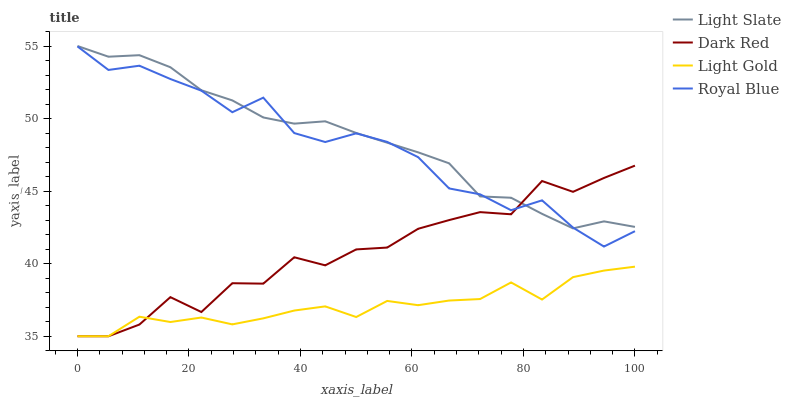Does Light Gold have the minimum area under the curve?
Answer yes or no. Yes. Does Light Slate have the maximum area under the curve?
Answer yes or no. Yes. Does Dark Red have the minimum area under the curve?
Answer yes or no. No. Does Dark Red have the maximum area under the curve?
Answer yes or no. No. Is Light Slate the smoothest?
Answer yes or no. Yes. Is Dark Red the roughest?
Answer yes or no. Yes. Is Light Gold the smoothest?
Answer yes or no. No. Is Light Gold the roughest?
Answer yes or no. No. Does Royal Blue have the lowest value?
Answer yes or no. No. Does Dark Red have the highest value?
Answer yes or no. No. Is Light Gold less than Royal Blue?
Answer yes or no. Yes. Is Light Slate greater than Light Gold?
Answer yes or no. Yes. Does Light Gold intersect Royal Blue?
Answer yes or no. No. 